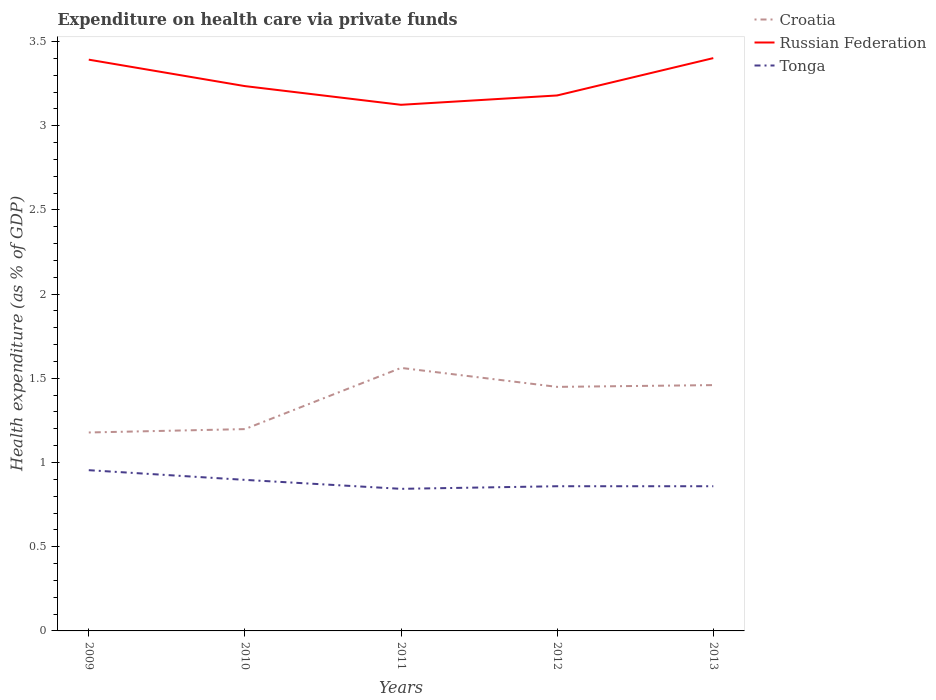Is the number of lines equal to the number of legend labels?
Offer a terse response. Yes. Across all years, what is the maximum expenditure made on health care in Russian Federation?
Your response must be concise. 3.12. In which year was the expenditure made on health care in Russian Federation maximum?
Provide a succinct answer. 2011. What is the total expenditure made on health care in Russian Federation in the graph?
Provide a short and direct response. -0.06. What is the difference between the highest and the second highest expenditure made on health care in Russian Federation?
Give a very brief answer. 0.28. How many years are there in the graph?
Your answer should be compact. 5. What is the difference between two consecutive major ticks on the Y-axis?
Offer a terse response. 0.5. Does the graph contain grids?
Offer a terse response. No. How many legend labels are there?
Keep it short and to the point. 3. What is the title of the graph?
Provide a short and direct response. Expenditure on health care via private funds. What is the label or title of the Y-axis?
Give a very brief answer. Health expenditure (as % of GDP). What is the Health expenditure (as % of GDP) in Croatia in 2009?
Ensure brevity in your answer.  1.18. What is the Health expenditure (as % of GDP) in Russian Federation in 2009?
Offer a very short reply. 3.39. What is the Health expenditure (as % of GDP) of Tonga in 2009?
Give a very brief answer. 0.95. What is the Health expenditure (as % of GDP) in Croatia in 2010?
Ensure brevity in your answer.  1.2. What is the Health expenditure (as % of GDP) of Russian Federation in 2010?
Offer a very short reply. 3.23. What is the Health expenditure (as % of GDP) in Tonga in 2010?
Ensure brevity in your answer.  0.9. What is the Health expenditure (as % of GDP) of Croatia in 2011?
Offer a very short reply. 1.56. What is the Health expenditure (as % of GDP) of Russian Federation in 2011?
Your answer should be very brief. 3.12. What is the Health expenditure (as % of GDP) of Tonga in 2011?
Your response must be concise. 0.84. What is the Health expenditure (as % of GDP) in Croatia in 2012?
Your response must be concise. 1.45. What is the Health expenditure (as % of GDP) of Russian Federation in 2012?
Ensure brevity in your answer.  3.18. What is the Health expenditure (as % of GDP) in Tonga in 2012?
Make the answer very short. 0.86. What is the Health expenditure (as % of GDP) of Croatia in 2013?
Make the answer very short. 1.46. What is the Health expenditure (as % of GDP) in Russian Federation in 2013?
Provide a short and direct response. 3.4. What is the Health expenditure (as % of GDP) in Tonga in 2013?
Offer a very short reply. 0.86. Across all years, what is the maximum Health expenditure (as % of GDP) of Croatia?
Provide a short and direct response. 1.56. Across all years, what is the maximum Health expenditure (as % of GDP) in Russian Federation?
Give a very brief answer. 3.4. Across all years, what is the maximum Health expenditure (as % of GDP) in Tonga?
Your response must be concise. 0.95. Across all years, what is the minimum Health expenditure (as % of GDP) in Croatia?
Make the answer very short. 1.18. Across all years, what is the minimum Health expenditure (as % of GDP) of Russian Federation?
Keep it short and to the point. 3.12. Across all years, what is the minimum Health expenditure (as % of GDP) in Tonga?
Your answer should be compact. 0.84. What is the total Health expenditure (as % of GDP) in Croatia in the graph?
Your answer should be compact. 6.85. What is the total Health expenditure (as % of GDP) in Russian Federation in the graph?
Provide a succinct answer. 16.33. What is the total Health expenditure (as % of GDP) of Tonga in the graph?
Your response must be concise. 4.41. What is the difference between the Health expenditure (as % of GDP) of Croatia in 2009 and that in 2010?
Make the answer very short. -0.02. What is the difference between the Health expenditure (as % of GDP) in Russian Federation in 2009 and that in 2010?
Provide a short and direct response. 0.16. What is the difference between the Health expenditure (as % of GDP) of Tonga in 2009 and that in 2010?
Offer a very short reply. 0.06. What is the difference between the Health expenditure (as % of GDP) of Croatia in 2009 and that in 2011?
Provide a short and direct response. -0.38. What is the difference between the Health expenditure (as % of GDP) of Russian Federation in 2009 and that in 2011?
Make the answer very short. 0.27. What is the difference between the Health expenditure (as % of GDP) of Tonga in 2009 and that in 2011?
Offer a very short reply. 0.11. What is the difference between the Health expenditure (as % of GDP) in Croatia in 2009 and that in 2012?
Provide a short and direct response. -0.27. What is the difference between the Health expenditure (as % of GDP) of Russian Federation in 2009 and that in 2012?
Make the answer very short. 0.21. What is the difference between the Health expenditure (as % of GDP) of Tonga in 2009 and that in 2012?
Give a very brief answer. 0.1. What is the difference between the Health expenditure (as % of GDP) of Croatia in 2009 and that in 2013?
Provide a short and direct response. -0.28. What is the difference between the Health expenditure (as % of GDP) in Russian Federation in 2009 and that in 2013?
Your response must be concise. -0.01. What is the difference between the Health expenditure (as % of GDP) in Tonga in 2009 and that in 2013?
Your response must be concise. 0.1. What is the difference between the Health expenditure (as % of GDP) of Croatia in 2010 and that in 2011?
Provide a short and direct response. -0.36. What is the difference between the Health expenditure (as % of GDP) of Russian Federation in 2010 and that in 2011?
Your answer should be compact. 0.11. What is the difference between the Health expenditure (as % of GDP) of Tonga in 2010 and that in 2011?
Your response must be concise. 0.05. What is the difference between the Health expenditure (as % of GDP) in Croatia in 2010 and that in 2012?
Ensure brevity in your answer.  -0.25. What is the difference between the Health expenditure (as % of GDP) of Russian Federation in 2010 and that in 2012?
Offer a terse response. 0.06. What is the difference between the Health expenditure (as % of GDP) in Tonga in 2010 and that in 2012?
Ensure brevity in your answer.  0.04. What is the difference between the Health expenditure (as % of GDP) of Croatia in 2010 and that in 2013?
Your answer should be very brief. -0.26. What is the difference between the Health expenditure (as % of GDP) in Russian Federation in 2010 and that in 2013?
Your response must be concise. -0.17. What is the difference between the Health expenditure (as % of GDP) in Tonga in 2010 and that in 2013?
Your response must be concise. 0.04. What is the difference between the Health expenditure (as % of GDP) in Croatia in 2011 and that in 2012?
Make the answer very short. 0.11. What is the difference between the Health expenditure (as % of GDP) of Russian Federation in 2011 and that in 2012?
Offer a terse response. -0.06. What is the difference between the Health expenditure (as % of GDP) of Tonga in 2011 and that in 2012?
Keep it short and to the point. -0.02. What is the difference between the Health expenditure (as % of GDP) of Croatia in 2011 and that in 2013?
Your answer should be very brief. 0.1. What is the difference between the Health expenditure (as % of GDP) in Russian Federation in 2011 and that in 2013?
Provide a succinct answer. -0.28. What is the difference between the Health expenditure (as % of GDP) in Tonga in 2011 and that in 2013?
Offer a terse response. -0.02. What is the difference between the Health expenditure (as % of GDP) of Croatia in 2012 and that in 2013?
Your answer should be very brief. -0.01. What is the difference between the Health expenditure (as % of GDP) of Russian Federation in 2012 and that in 2013?
Your response must be concise. -0.22. What is the difference between the Health expenditure (as % of GDP) in Croatia in 2009 and the Health expenditure (as % of GDP) in Russian Federation in 2010?
Offer a terse response. -2.06. What is the difference between the Health expenditure (as % of GDP) of Croatia in 2009 and the Health expenditure (as % of GDP) of Tonga in 2010?
Offer a very short reply. 0.28. What is the difference between the Health expenditure (as % of GDP) of Russian Federation in 2009 and the Health expenditure (as % of GDP) of Tonga in 2010?
Provide a succinct answer. 2.5. What is the difference between the Health expenditure (as % of GDP) of Croatia in 2009 and the Health expenditure (as % of GDP) of Russian Federation in 2011?
Provide a short and direct response. -1.95. What is the difference between the Health expenditure (as % of GDP) in Croatia in 2009 and the Health expenditure (as % of GDP) in Tonga in 2011?
Make the answer very short. 0.33. What is the difference between the Health expenditure (as % of GDP) of Russian Federation in 2009 and the Health expenditure (as % of GDP) of Tonga in 2011?
Ensure brevity in your answer.  2.55. What is the difference between the Health expenditure (as % of GDP) in Croatia in 2009 and the Health expenditure (as % of GDP) in Russian Federation in 2012?
Ensure brevity in your answer.  -2. What is the difference between the Health expenditure (as % of GDP) in Croatia in 2009 and the Health expenditure (as % of GDP) in Tonga in 2012?
Offer a terse response. 0.32. What is the difference between the Health expenditure (as % of GDP) of Russian Federation in 2009 and the Health expenditure (as % of GDP) of Tonga in 2012?
Give a very brief answer. 2.53. What is the difference between the Health expenditure (as % of GDP) of Croatia in 2009 and the Health expenditure (as % of GDP) of Russian Federation in 2013?
Your response must be concise. -2.22. What is the difference between the Health expenditure (as % of GDP) of Croatia in 2009 and the Health expenditure (as % of GDP) of Tonga in 2013?
Ensure brevity in your answer.  0.32. What is the difference between the Health expenditure (as % of GDP) in Russian Federation in 2009 and the Health expenditure (as % of GDP) in Tonga in 2013?
Make the answer very short. 2.53. What is the difference between the Health expenditure (as % of GDP) in Croatia in 2010 and the Health expenditure (as % of GDP) in Russian Federation in 2011?
Provide a succinct answer. -1.93. What is the difference between the Health expenditure (as % of GDP) of Croatia in 2010 and the Health expenditure (as % of GDP) of Tonga in 2011?
Your answer should be compact. 0.35. What is the difference between the Health expenditure (as % of GDP) in Russian Federation in 2010 and the Health expenditure (as % of GDP) in Tonga in 2011?
Offer a very short reply. 2.39. What is the difference between the Health expenditure (as % of GDP) in Croatia in 2010 and the Health expenditure (as % of GDP) in Russian Federation in 2012?
Your answer should be very brief. -1.98. What is the difference between the Health expenditure (as % of GDP) in Croatia in 2010 and the Health expenditure (as % of GDP) in Tonga in 2012?
Ensure brevity in your answer.  0.34. What is the difference between the Health expenditure (as % of GDP) of Russian Federation in 2010 and the Health expenditure (as % of GDP) of Tonga in 2012?
Provide a short and direct response. 2.38. What is the difference between the Health expenditure (as % of GDP) in Croatia in 2010 and the Health expenditure (as % of GDP) in Russian Federation in 2013?
Provide a succinct answer. -2.2. What is the difference between the Health expenditure (as % of GDP) in Croatia in 2010 and the Health expenditure (as % of GDP) in Tonga in 2013?
Offer a very short reply. 0.34. What is the difference between the Health expenditure (as % of GDP) of Russian Federation in 2010 and the Health expenditure (as % of GDP) of Tonga in 2013?
Offer a very short reply. 2.38. What is the difference between the Health expenditure (as % of GDP) of Croatia in 2011 and the Health expenditure (as % of GDP) of Russian Federation in 2012?
Keep it short and to the point. -1.62. What is the difference between the Health expenditure (as % of GDP) of Croatia in 2011 and the Health expenditure (as % of GDP) of Tonga in 2012?
Make the answer very short. 0.7. What is the difference between the Health expenditure (as % of GDP) of Russian Federation in 2011 and the Health expenditure (as % of GDP) of Tonga in 2012?
Give a very brief answer. 2.26. What is the difference between the Health expenditure (as % of GDP) in Croatia in 2011 and the Health expenditure (as % of GDP) in Russian Federation in 2013?
Give a very brief answer. -1.84. What is the difference between the Health expenditure (as % of GDP) in Croatia in 2011 and the Health expenditure (as % of GDP) in Tonga in 2013?
Keep it short and to the point. 0.7. What is the difference between the Health expenditure (as % of GDP) in Russian Federation in 2011 and the Health expenditure (as % of GDP) in Tonga in 2013?
Your answer should be compact. 2.26. What is the difference between the Health expenditure (as % of GDP) in Croatia in 2012 and the Health expenditure (as % of GDP) in Russian Federation in 2013?
Ensure brevity in your answer.  -1.95. What is the difference between the Health expenditure (as % of GDP) in Croatia in 2012 and the Health expenditure (as % of GDP) in Tonga in 2013?
Offer a very short reply. 0.59. What is the difference between the Health expenditure (as % of GDP) in Russian Federation in 2012 and the Health expenditure (as % of GDP) in Tonga in 2013?
Make the answer very short. 2.32. What is the average Health expenditure (as % of GDP) of Croatia per year?
Provide a short and direct response. 1.37. What is the average Health expenditure (as % of GDP) of Russian Federation per year?
Provide a short and direct response. 3.27. What is the average Health expenditure (as % of GDP) of Tonga per year?
Offer a very short reply. 0.88. In the year 2009, what is the difference between the Health expenditure (as % of GDP) of Croatia and Health expenditure (as % of GDP) of Russian Federation?
Your answer should be compact. -2.21. In the year 2009, what is the difference between the Health expenditure (as % of GDP) of Croatia and Health expenditure (as % of GDP) of Tonga?
Keep it short and to the point. 0.22. In the year 2009, what is the difference between the Health expenditure (as % of GDP) of Russian Federation and Health expenditure (as % of GDP) of Tonga?
Your response must be concise. 2.44. In the year 2010, what is the difference between the Health expenditure (as % of GDP) in Croatia and Health expenditure (as % of GDP) in Russian Federation?
Offer a terse response. -2.04. In the year 2010, what is the difference between the Health expenditure (as % of GDP) in Croatia and Health expenditure (as % of GDP) in Tonga?
Your answer should be very brief. 0.3. In the year 2010, what is the difference between the Health expenditure (as % of GDP) in Russian Federation and Health expenditure (as % of GDP) in Tonga?
Make the answer very short. 2.34. In the year 2011, what is the difference between the Health expenditure (as % of GDP) in Croatia and Health expenditure (as % of GDP) in Russian Federation?
Keep it short and to the point. -1.56. In the year 2011, what is the difference between the Health expenditure (as % of GDP) in Croatia and Health expenditure (as % of GDP) in Tonga?
Your answer should be compact. 0.72. In the year 2011, what is the difference between the Health expenditure (as % of GDP) of Russian Federation and Health expenditure (as % of GDP) of Tonga?
Ensure brevity in your answer.  2.28. In the year 2012, what is the difference between the Health expenditure (as % of GDP) in Croatia and Health expenditure (as % of GDP) in Russian Federation?
Your answer should be very brief. -1.73. In the year 2012, what is the difference between the Health expenditure (as % of GDP) in Croatia and Health expenditure (as % of GDP) in Tonga?
Your answer should be compact. 0.59. In the year 2012, what is the difference between the Health expenditure (as % of GDP) of Russian Federation and Health expenditure (as % of GDP) of Tonga?
Give a very brief answer. 2.32. In the year 2013, what is the difference between the Health expenditure (as % of GDP) of Croatia and Health expenditure (as % of GDP) of Russian Federation?
Your answer should be very brief. -1.94. In the year 2013, what is the difference between the Health expenditure (as % of GDP) in Croatia and Health expenditure (as % of GDP) in Tonga?
Offer a terse response. 0.6. In the year 2013, what is the difference between the Health expenditure (as % of GDP) in Russian Federation and Health expenditure (as % of GDP) in Tonga?
Your answer should be very brief. 2.54. What is the ratio of the Health expenditure (as % of GDP) of Croatia in 2009 to that in 2010?
Your answer should be very brief. 0.98. What is the ratio of the Health expenditure (as % of GDP) of Russian Federation in 2009 to that in 2010?
Offer a very short reply. 1.05. What is the ratio of the Health expenditure (as % of GDP) in Tonga in 2009 to that in 2010?
Make the answer very short. 1.06. What is the ratio of the Health expenditure (as % of GDP) in Croatia in 2009 to that in 2011?
Ensure brevity in your answer.  0.75. What is the ratio of the Health expenditure (as % of GDP) of Russian Federation in 2009 to that in 2011?
Keep it short and to the point. 1.09. What is the ratio of the Health expenditure (as % of GDP) of Tonga in 2009 to that in 2011?
Keep it short and to the point. 1.13. What is the ratio of the Health expenditure (as % of GDP) of Croatia in 2009 to that in 2012?
Provide a succinct answer. 0.81. What is the ratio of the Health expenditure (as % of GDP) in Russian Federation in 2009 to that in 2012?
Your answer should be very brief. 1.07. What is the ratio of the Health expenditure (as % of GDP) of Tonga in 2009 to that in 2012?
Provide a short and direct response. 1.11. What is the ratio of the Health expenditure (as % of GDP) in Croatia in 2009 to that in 2013?
Your response must be concise. 0.81. What is the ratio of the Health expenditure (as % of GDP) in Russian Federation in 2009 to that in 2013?
Your response must be concise. 1. What is the ratio of the Health expenditure (as % of GDP) in Tonga in 2009 to that in 2013?
Offer a very short reply. 1.11. What is the ratio of the Health expenditure (as % of GDP) of Croatia in 2010 to that in 2011?
Your answer should be compact. 0.77. What is the ratio of the Health expenditure (as % of GDP) of Russian Federation in 2010 to that in 2011?
Your response must be concise. 1.04. What is the ratio of the Health expenditure (as % of GDP) of Tonga in 2010 to that in 2011?
Provide a short and direct response. 1.06. What is the ratio of the Health expenditure (as % of GDP) in Croatia in 2010 to that in 2012?
Your answer should be very brief. 0.83. What is the ratio of the Health expenditure (as % of GDP) of Russian Federation in 2010 to that in 2012?
Ensure brevity in your answer.  1.02. What is the ratio of the Health expenditure (as % of GDP) of Tonga in 2010 to that in 2012?
Your answer should be compact. 1.04. What is the ratio of the Health expenditure (as % of GDP) of Croatia in 2010 to that in 2013?
Provide a succinct answer. 0.82. What is the ratio of the Health expenditure (as % of GDP) in Russian Federation in 2010 to that in 2013?
Offer a very short reply. 0.95. What is the ratio of the Health expenditure (as % of GDP) of Tonga in 2010 to that in 2013?
Ensure brevity in your answer.  1.04. What is the ratio of the Health expenditure (as % of GDP) in Croatia in 2011 to that in 2012?
Ensure brevity in your answer.  1.08. What is the ratio of the Health expenditure (as % of GDP) in Russian Federation in 2011 to that in 2012?
Offer a very short reply. 0.98. What is the ratio of the Health expenditure (as % of GDP) of Croatia in 2011 to that in 2013?
Keep it short and to the point. 1.07. What is the ratio of the Health expenditure (as % of GDP) in Russian Federation in 2011 to that in 2013?
Ensure brevity in your answer.  0.92. What is the ratio of the Health expenditure (as % of GDP) in Croatia in 2012 to that in 2013?
Provide a succinct answer. 0.99. What is the ratio of the Health expenditure (as % of GDP) in Russian Federation in 2012 to that in 2013?
Make the answer very short. 0.93. What is the difference between the highest and the second highest Health expenditure (as % of GDP) of Croatia?
Provide a short and direct response. 0.1. What is the difference between the highest and the second highest Health expenditure (as % of GDP) in Russian Federation?
Ensure brevity in your answer.  0.01. What is the difference between the highest and the second highest Health expenditure (as % of GDP) of Tonga?
Ensure brevity in your answer.  0.06. What is the difference between the highest and the lowest Health expenditure (as % of GDP) of Croatia?
Your answer should be very brief. 0.38. What is the difference between the highest and the lowest Health expenditure (as % of GDP) of Russian Federation?
Provide a short and direct response. 0.28. What is the difference between the highest and the lowest Health expenditure (as % of GDP) of Tonga?
Provide a succinct answer. 0.11. 